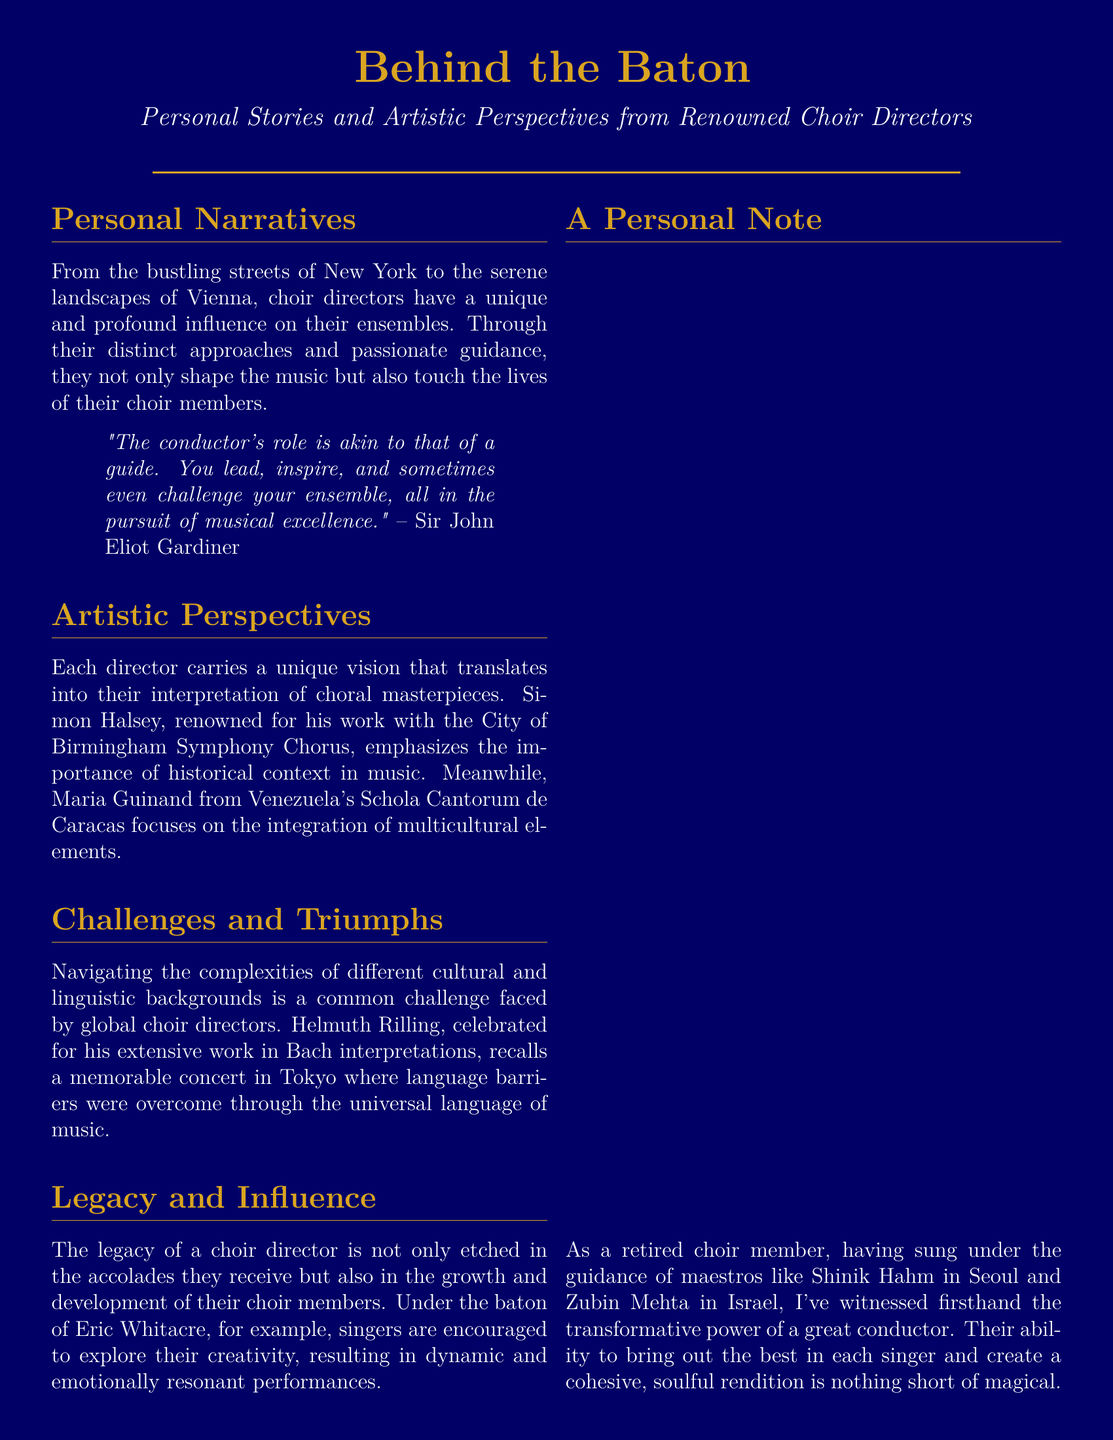What is the title of the Playbill? The title is prominently displayed at the top, highlighting the theme of the document.
Answer: Behind the Baton Who is quoted in the Personal Narratives section? The quote includes the name of an influential choir director, indicating their perspective.
Answer: Sir John Eliot Gardiner Which choir is Simon Halsey associated with? The document specifies Simon Halsey's notable affiliations within a specific musical context.
Answer: City of Birmingham Symphony Chorus What is a common challenge faced by choir directors? The document discusses the difficulties that arise in a multicultural setting among choir directors.
Answer: Language barriers Who is known for his work in Bach interpretations? The document mentions several notable directors, identifying their specialties.
Answer: Helmuth Rilling What concept does Eric Whitacre encourage in singers? The Playbill emphasizes the artistic approach that a particular director fosters in his choir.
Answer: Creativity What is the production date of this Playbill? The document lists a specific date related to the creation of this material.
Answer: October 2023 Who is the document dedicated to? The dedication reflects the overarching theme of appreciation emphasized in the Playbill.
Answer: Choir directors worldwide 